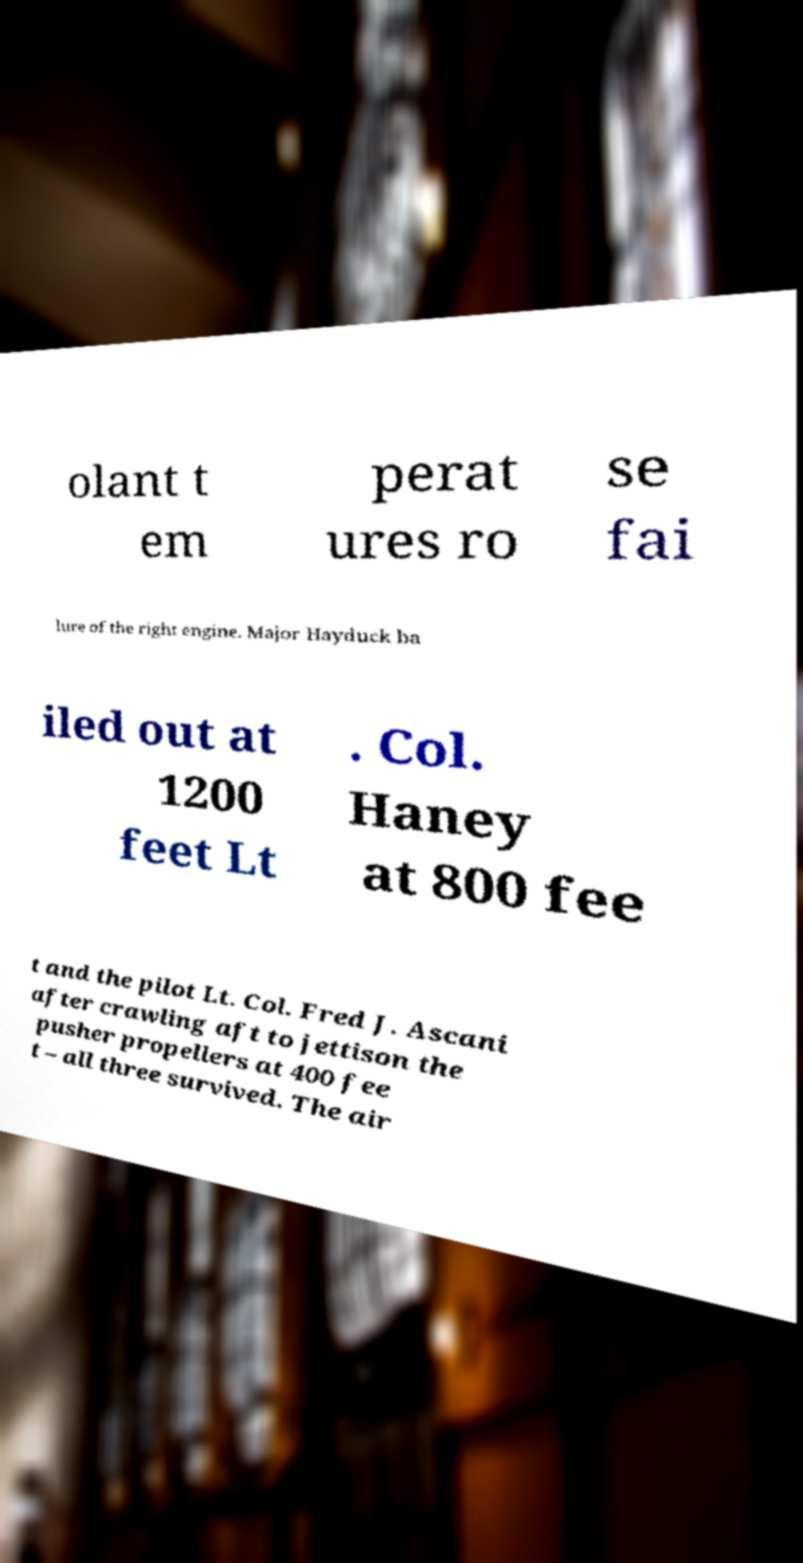Please identify and transcribe the text found in this image. olant t em perat ures ro se fai lure of the right engine. Major Hayduck ba iled out at 1200 feet Lt . Col. Haney at 800 fee t and the pilot Lt. Col. Fred J. Ascani after crawling aft to jettison the pusher propellers at 400 fee t – all three survived. The air 